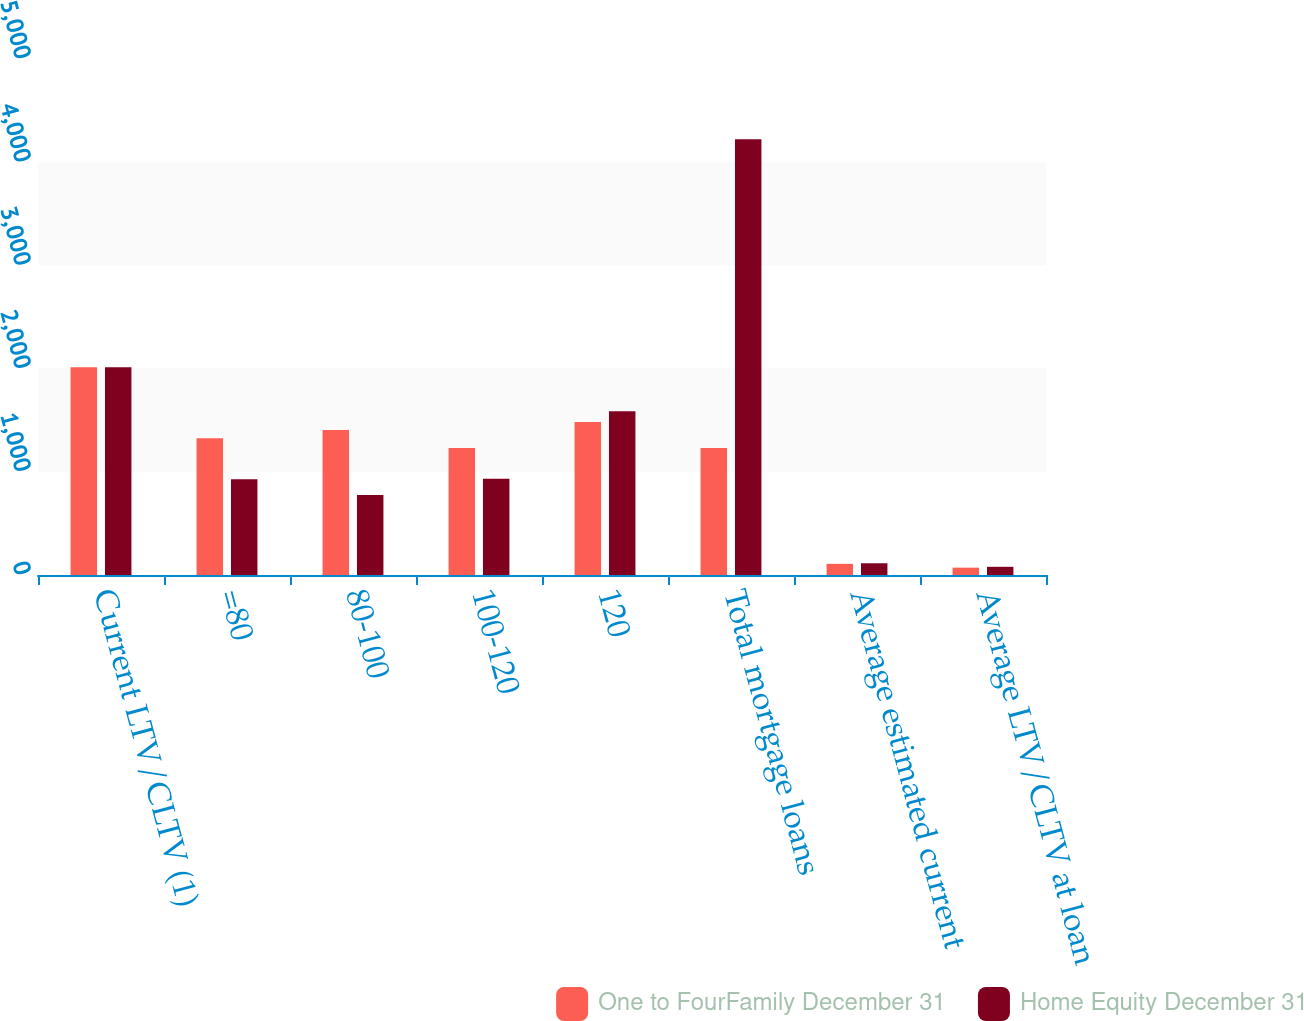Convert chart to OTSL. <chart><loc_0><loc_0><loc_500><loc_500><stacked_bar_chart><ecel><fcel>Current LTV/CLTV (1)<fcel>=80<fcel>80-100<fcel>100-120<fcel>120<fcel>Total mortgage loans<fcel>Average estimated current<fcel>Average LTV/CLTV at loan<nl><fcel>One to FourFamily December 31<fcel>2012<fcel>1324.2<fcel>1404.4<fcel>1231.5<fcel>1482.1<fcel>1231.5<fcel>108.1<fcel>71.2<nl><fcel>Home Equity December 31<fcel>2012<fcel>927.5<fcel>776.2<fcel>932<fcel>1587.7<fcel>4223.4<fcel>113.8<fcel>79.4<nl></chart> 